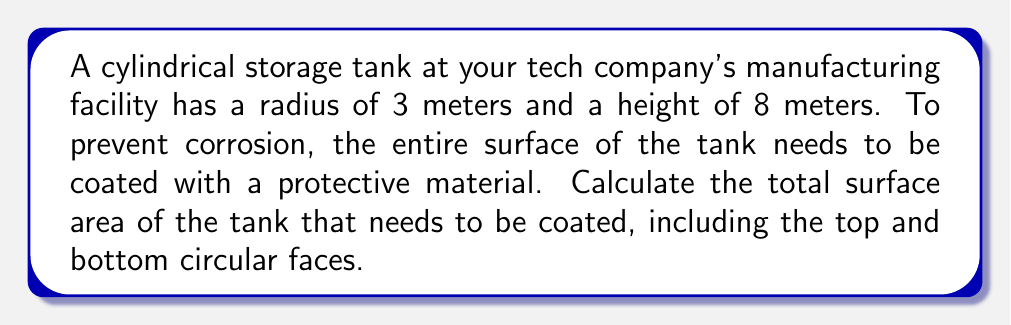Teach me how to tackle this problem. To calculate the surface area of a cylindrical tank, we need to consider three components:
1. The lateral surface area (curved side)
2. The top circular face
3. The bottom circular face

Let's solve this step-by-step:

1. Lateral surface area:
   The formula for the lateral surface area of a cylinder is $A_l = 2\pi rh$
   where $r$ is the radius and $h$ is the height.
   
   $A_l = 2\pi \cdot 3 \cdot 8 = 48\pi$ m²

2. Area of top and bottom circular faces:
   The formula for the area of a circle is $A_c = \pi r^2$
   We need this twice (top and bottom).
   
   $A_c = 2 \cdot \pi r^2 = 2 \cdot \pi \cdot 3^2 = 18\pi$ m²

3. Total surface area:
   Sum the lateral surface area and the areas of the circular faces.
   
   $A_{total} = A_l + A_c = 48\pi + 18\pi = 66\pi$ m²

Converting to a decimal:
$A_{total} = 66\pi \approx 207.35$ m²
Answer: $207.35$ m² 